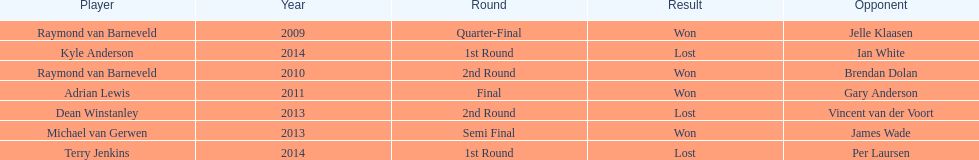Out of the listed players, who are the only ones that played in 2011? Adrian Lewis. Would you mind parsing the complete table? {'header': ['Player', 'Year', 'Round', 'Result', 'Opponent'], 'rows': [['Raymond van Barneveld', '2009', 'Quarter-Final', 'Won', 'Jelle Klaasen'], ['Kyle Anderson', '2014', '1st Round', 'Lost', 'Ian White'], ['Raymond van Barneveld', '2010', '2nd Round', 'Won', 'Brendan Dolan'], ['Adrian Lewis', '2011', 'Final', 'Won', 'Gary Anderson'], ['Dean Winstanley', '2013', '2nd Round', 'Lost', 'Vincent van der Voort'], ['Michael van Gerwen', '2013', 'Semi Final', 'Won', 'James Wade'], ['Terry Jenkins', '2014', '1st Round', 'Lost', 'Per Laursen']]} 